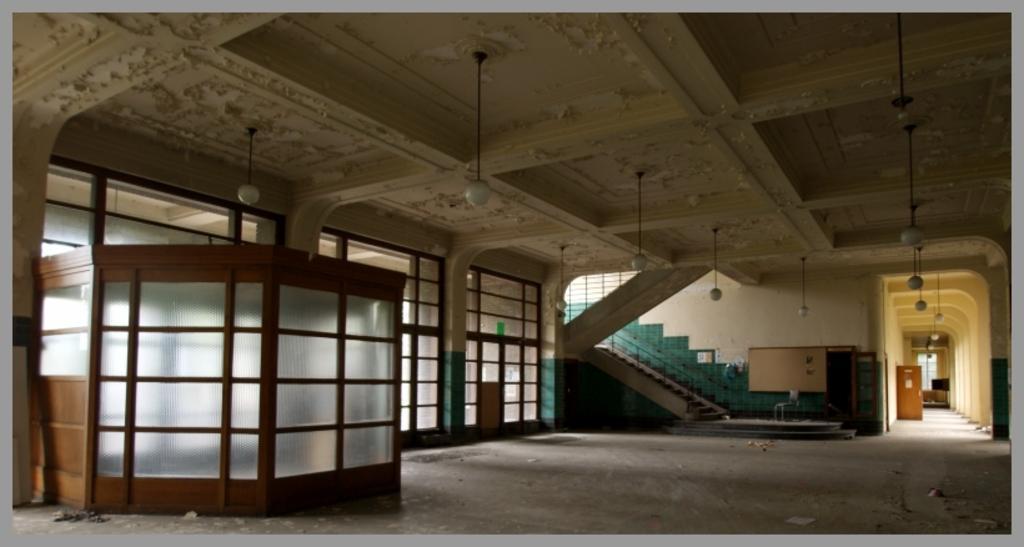Can you describe this image briefly? This image is taken inside the building. In this image we can see the glass cabin, windows, stairs, wall and also the door. We can also see the floor. At the top we can see the ceiling with the lights. 